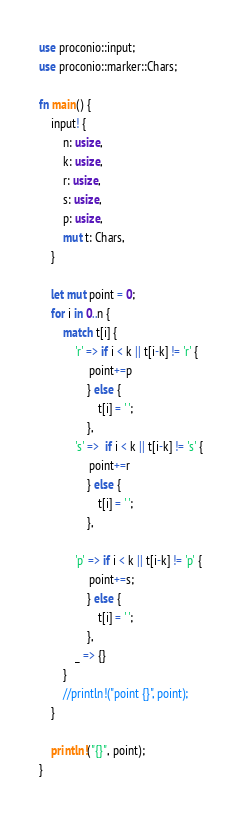<code> <loc_0><loc_0><loc_500><loc_500><_Rust_>use proconio::input;
use proconio::marker::Chars;

fn main() {
    input! {
        n: usize,
        k: usize,
        r: usize,
        s: usize,
        p: usize,
        mut t: Chars,
    }

    let mut point = 0;
    for i in 0..n {
        match t[i] {
            'r' => if i < k || t[i-k] != 'r' {
                 point+=p
                } else {
                    t[i] = ' ';
                },
            's' =>  if i < k || t[i-k] != 's' {
                 point+=r
                } else {
                    t[i] = ' ';
                },

            'p' => if i < k || t[i-k] != 'p' {
                 point+=s;
                } else {
                    t[i] = ' ';
                },
            _ => {}
        }
        //println!("point {}", point);
    }

    println!("{}", point);
}
</code> 